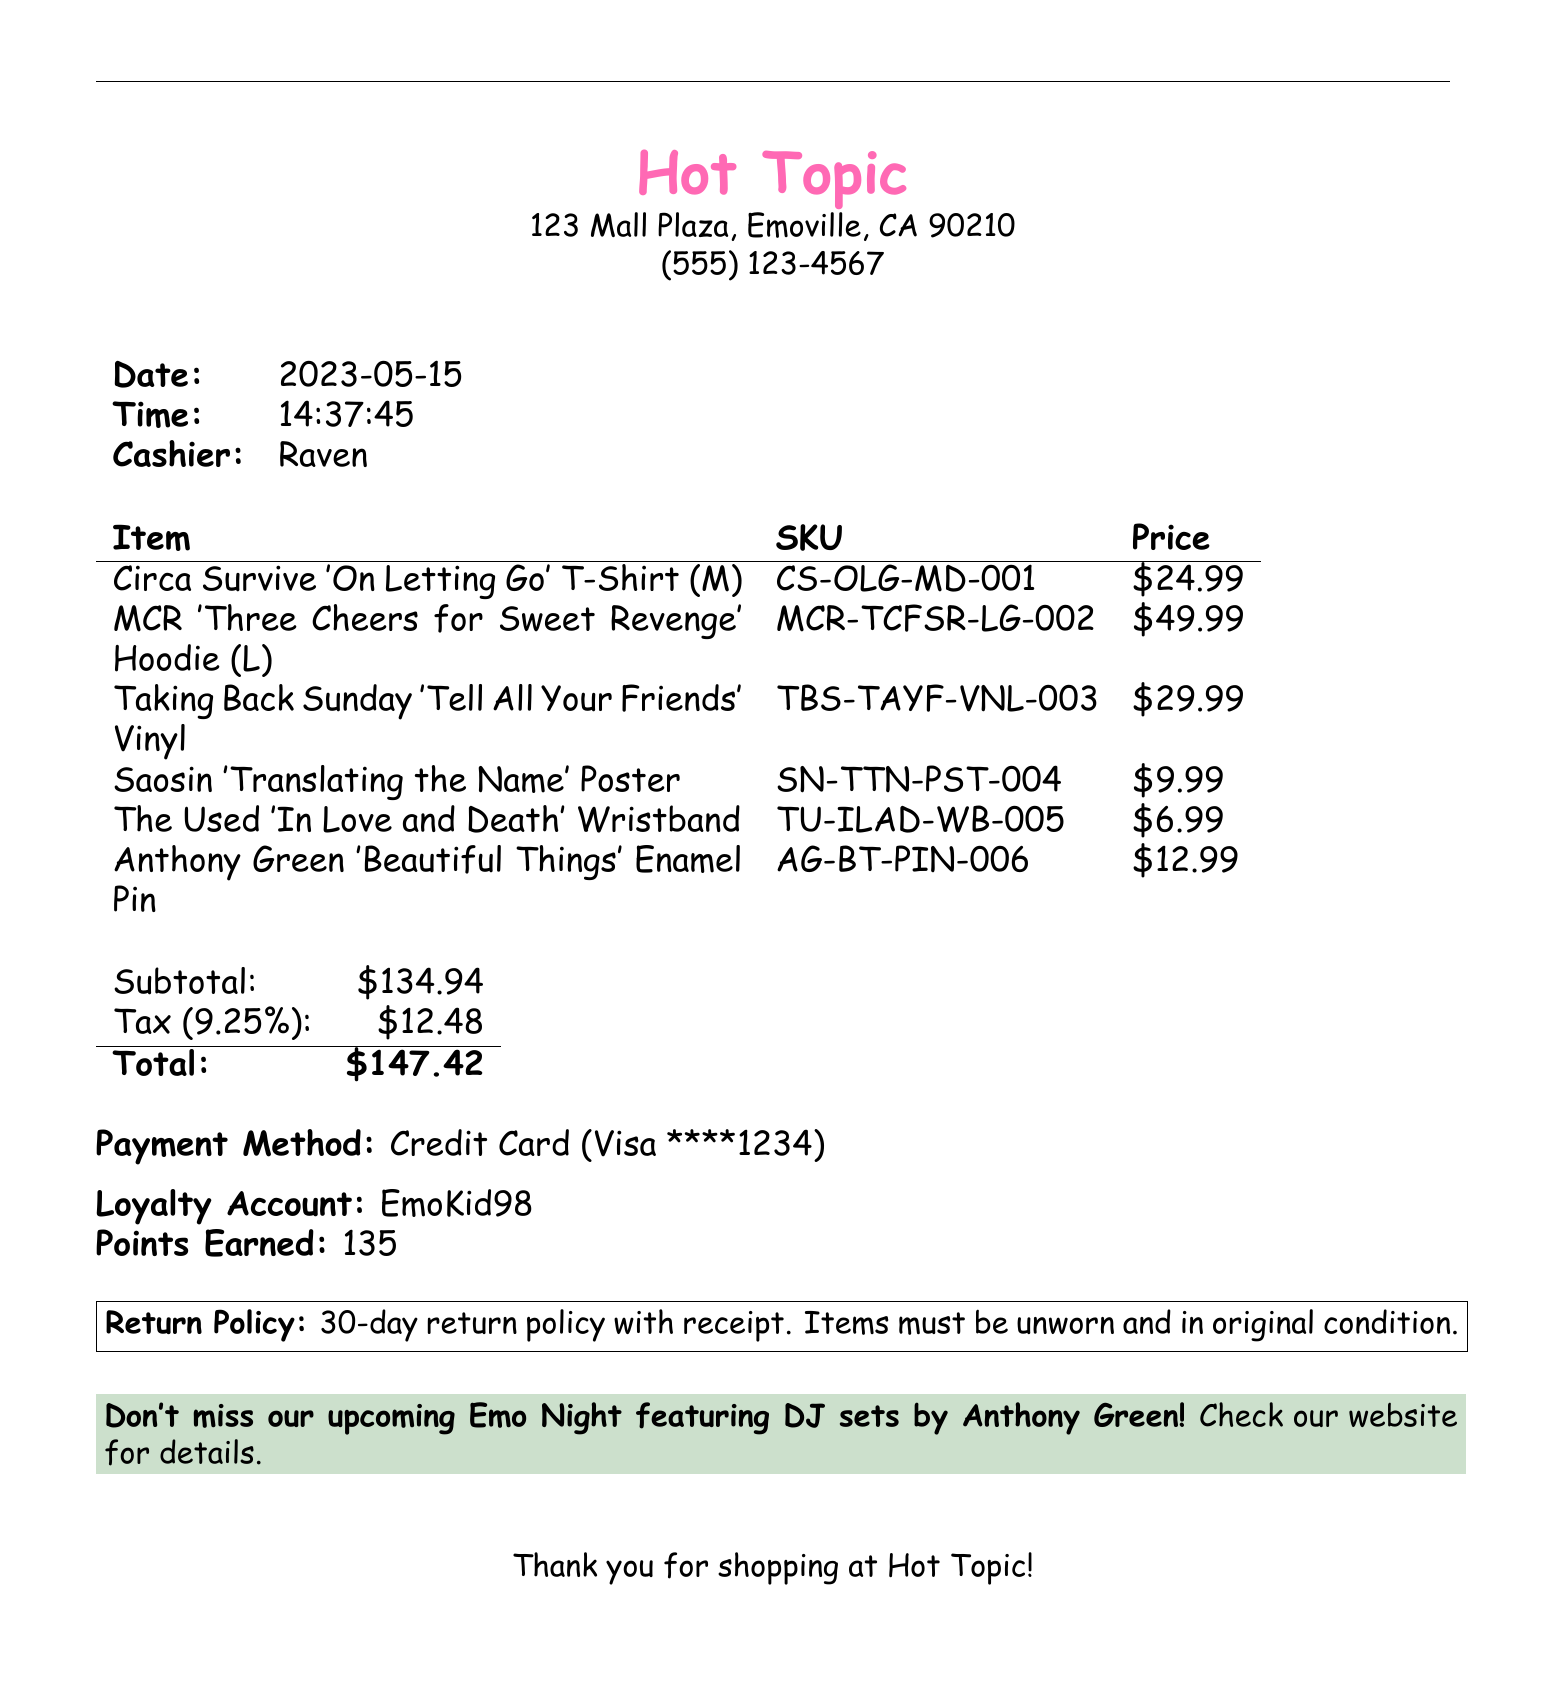What is the store name? The store name is prominently displayed at the top of the receipt.
Answer: Hot Topic What is the date of the transaction? The transaction date is listed in the document next to "Date:."
Answer: 2023-05-15 Who was the cashier? The name of the cashier is mentioned under the transaction details.
Answer: Raven How many loyalty points were earned? The loyalty points earned are provided in the loyalty section of the receipt.
Answer: 135 What is the tax amount? The tax amount is calculated and listed next to the subtotal.
Answer: 12.48 What payment method was used? The payment method is specified in the payment section.
Answer: Credit Card Which item had the highest price? The prices of the items are listed; the hoodie is the most expensive.
Answer: My Chemical Romance 'Three Cheers for Sweet Revenge' Hoodie What is the return policy? The return policy is outlined in a boxed section near the bottom of the receipt.
Answer: 30-day return policy with receipt What is advertised at the bottom of the receipt? The promotional message at the bottom encourages participation in an event.
Answer: Emo Night featuring DJ sets by Anthony Green What size is the Anthony Green enamel pin? The size or additional specifications about the pin are not shown, but its placement implies it’s a standard item.
Answer: N/A 